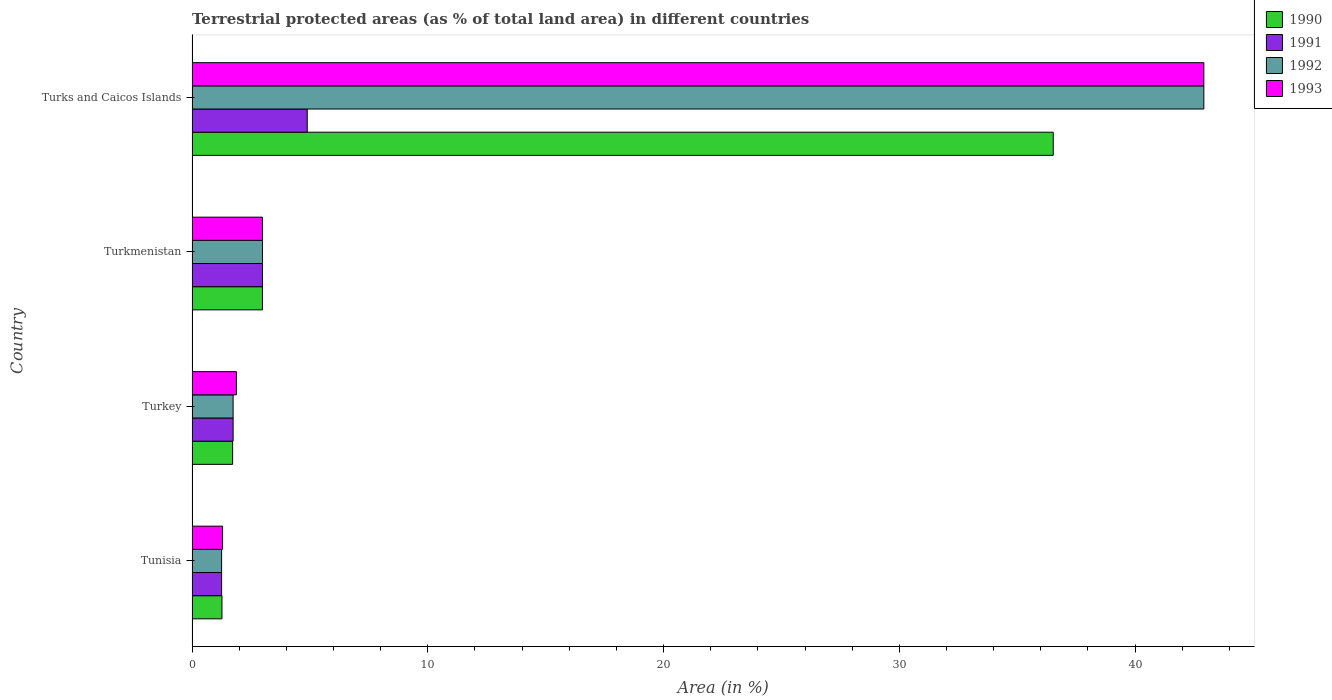Are the number of bars per tick equal to the number of legend labels?
Provide a succinct answer. Yes. Are the number of bars on each tick of the Y-axis equal?
Provide a succinct answer. Yes. How many bars are there on the 3rd tick from the top?
Provide a succinct answer. 4. How many bars are there on the 2nd tick from the bottom?
Ensure brevity in your answer.  4. What is the label of the 1st group of bars from the top?
Provide a short and direct response. Turks and Caicos Islands. What is the percentage of terrestrial protected land in 1990 in Turks and Caicos Islands?
Ensure brevity in your answer.  36.53. Across all countries, what is the maximum percentage of terrestrial protected land in 1992?
Keep it short and to the point. 42.92. Across all countries, what is the minimum percentage of terrestrial protected land in 1992?
Offer a very short reply. 1.25. In which country was the percentage of terrestrial protected land in 1993 maximum?
Keep it short and to the point. Turks and Caicos Islands. In which country was the percentage of terrestrial protected land in 1992 minimum?
Give a very brief answer. Tunisia. What is the total percentage of terrestrial protected land in 1991 in the graph?
Your answer should be very brief. 10.87. What is the difference between the percentage of terrestrial protected land in 1993 in Tunisia and that in Turkey?
Keep it short and to the point. -0.59. What is the difference between the percentage of terrestrial protected land in 1991 in Tunisia and the percentage of terrestrial protected land in 1992 in Turkey?
Provide a succinct answer. -0.49. What is the average percentage of terrestrial protected land in 1990 per country?
Keep it short and to the point. 10.63. What is the difference between the percentage of terrestrial protected land in 1990 and percentage of terrestrial protected land in 1993 in Tunisia?
Offer a terse response. -0.03. In how many countries, is the percentage of terrestrial protected land in 1993 greater than 12 %?
Make the answer very short. 1. What is the ratio of the percentage of terrestrial protected land in 1990 in Tunisia to that in Turkey?
Provide a succinct answer. 0.74. Is the percentage of terrestrial protected land in 1991 in Tunisia less than that in Turks and Caicos Islands?
Make the answer very short. Yes. What is the difference between the highest and the second highest percentage of terrestrial protected land in 1991?
Keep it short and to the point. 1.9. What is the difference between the highest and the lowest percentage of terrestrial protected land in 1992?
Your answer should be very brief. 41.66. In how many countries, is the percentage of terrestrial protected land in 1991 greater than the average percentage of terrestrial protected land in 1991 taken over all countries?
Your answer should be compact. 2. Is the sum of the percentage of terrestrial protected land in 1993 in Turkey and Turks and Caicos Islands greater than the maximum percentage of terrestrial protected land in 1992 across all countries?
Provide a short and direct response. Yes. What does the 3rd bar from the bottom in Tunisia represents?
Ensure brevity in your answer.  1992. What is the difference between two consecutive major ticks on the X-axis?
Keep it short and to the point. 10. Are the values on the major ticks of X-axis written in scientific E-notation?
Your answer should be compact. No. How many legend labels are there?
Offer a terse response. 4. What is the title of the graph?
Provide a succinct answer. Terrestrial protected areas (as % of total land area) in different countries. What is the label or title of the X-axis?
Offer a terse response. Area (in %). What is the Area (in %) in 1990 in Tunisia?
Your response must be concise. 1.27. What is the Area (in %) of 1991 in Tunisia?
Provide a short and direct response. 1.25. What is the Area (in %) in 1992 in Tunisia?
Give a very brief answer. 1.25. What is the Area (in %) of 1993 in Tunisia?
Offer a very short reply. 1.29. What is the Area (in %) in 1990 in Turkey?
Your answer should be very brief. 1.72. What is the Area (in %) of 1991 in Turkey?
Offer a very short reply. 1.74. What is the Area (in %) of 1992 in Turkey?
Offer a very short reply. 1.74. What is the Area (in %) of 1993 in Turkey?
Ensure brevity in your answer.  1.88. What is the Area (in %) in 1990 in Turkmenistan?
Offer a terse response. 2.99. What is the Area (in %) of 1991 in Turkmenistan?
Offer a terse response. 2.99. What is the Area (in %) in 1992 in Turkmenistan?
Provide a succinct answer. 2.99. What is the Area (in %) of 1993 in Turkmenistan?
Keep it short and to the point. 2.99. What is the Area (in %) in 1990 in Turks and Caicos Islands?
Your answer should be very brief. 36.53. What is the Area (in %) of 1991 in Turks and Caicos Islands?
Make the answer very short. 4.89. What is the Area (in %) of 1992 in Turks and Caicos Islands?
Offer a terse response. 42.92. What is the Area (in %) of 1993 in Turks and Caicos Islands?
Ensure brevity in your answer.  42.92. Across all countries, what is the maximum Area (in %) of 1990?
Provide a succinct answer. 36.53. Across all countries, what is the maximum Area (in %) of 1991?
Make the answer very short. 4.89. Across all countries, what is the maximum Area (in %) of 1992?
Provide a succinct answer. 42.92. Across all countries, what is the maximum Area (in %) of 1993?
Provide a short and direct response. 42.92. Across all countries, what is the minimum Area (in %) of 1990?
Offer a terse response. 1.27. Across all countries, what is the minimum Area (in %) of 1991?
Keep it short and to the point. 1.25. Across all countries, what is the minimum Area (in %) in 1992?
Your answer should be very brief. 1.25. Across all countries, what is the minimum Area (in %) in 1993?
Ensure brevity in your answer.  1.29. What is the total Area (in %) in 1990 in the graph?
Ensure brevity in your answer.  42.5. What is the total Area (in %) in 1991 in the graph?
Keep it short and to the point. 10.87. What is the total Area (in %) in 1992 in the graph?
Provide a succinct answer. 48.9. What is the total Area (in %) in 1993 in the graph?
Ensure brevity in your answer.  49.08. What is the difference between the Area (in %) of 1990 in Tunisia and that in Turkey?
Your answer should be compact. -0.45. What is the difference between the Area (in %) in 1991 in Tunisia and that in Turkey?
Your answer should be compact. -0.49. What is the difference between the Area (in %) in 1992 in Tunisia and that in Turkey?
Your answer should be compact. -0.49. What is the difference between the Area (in %) in 1993 in Tunisia and that in Turkey?
Make the answer very short. -0.59. What is the difference between the Area (in %) in 1990 in Tunisia and that in Turkmenistan?
Offer a terse response. -1.72. What is the difference between the Area (in %) in 1991 in Tunisia and that in Turkmenistan?
Make the answer very short. -1.73. What is the difference between the Area (in %) of 1992 in Tunisia and that in Turkmenistan?
Offer a very short reply. -1.73. What is the difference between the Area (in %) in 1993 in Tunisia and that in Turkmenistan?
Give a very brief answer. -1.69. What is the difference between the Area (in %) in 1990 in Tunisia and that in Turks and Caicos Islands?
Provide a succinct answer. -35.26. What is the difference between the Area (in %) of 1991 in Tunisia and that in Turks and Caicos Islands?
Give a very brief answer. -3.63. What is the difference between the Area (in %) of 1992 in Tunisia and that in Turks and Caicos Islands?
Keep it short and to the point. -41.66. What is the difference between the Area (in %) in 1993 in Tunisia and that in Turks and Caicos Islands?
Provide a short and direct response. -41.62. What is the difference between the Area (in %) in 1990 in Turkey and that in Turkmenistan?
Keep it short and to the point. -1.27. What is the difference between the Area (in %) in 1991 in Turkey and that in Turkmenistan?
Give a very brief answer. -1.24. What is the difference between the Area (in %) in 1992 in Turkey and that in Turkmenistan?
Your response must be concise. -1.24. What is the difference between the Area (in %) of 1993 in Turkey and that in Turkmenistan?
Ensure brevity in your answer.  -1.1. What is the difference between the Area (in %) in 1990 in Turkey and that in Turks and Caicos Islands?
Ensure brevity in your answer.  -34.81. What is the difference between the Area (in %) in 1991 in Turkey and that in Turks and Caicos Islands?
Provide a succinct answer. -3.14. What is the difference between the Area (in %) of 1992 in Turkey and that in Turks and Caicos Islands?
Ensure brevity in your answer.  -41.18. What is the difference between the Area (in %) of 1993 in Turkey and that in Turks and Caicos Islands?
Make the answer very short. -41.04. What is the difference between the Area (in %) of 1990 in Turkmenistan and that in Turks and Caicos Islands?
Provide a short and direct response. -33.54. What is the difference between the Area (in %) in 1991 in Turkmenistan and that in Turks and Caicos Islands?
Your answer should be very brief. -1.9. What is the difference between the Area (in %) of 1992 in Turkmenistan and that in Turks and Caicos Islands?
Give a very brief answer. -39.93. What is the difference between the Area (in %) in 1993 in Turkmenistan and that in Turks and Caicos Islands?
Provide a short and direct response. -39.93. What is the difference between the Area (in %) in 1990 in Tunisia and the Area (in %) in 1991 in Turkey?
Offer a terse response. -0.47. What is the difference between the Area (in %) of 1990 in Tunisia and the Area (in %) of 1992 in Turkey?
Your response must be concise. -0.47. What is the difference between the Area (in %) of 1990 in Tunisia and the Area (in %) of 1993 in Turkey?
Ensure brevity in your answer.  -0.61. What is the difference between the Area (in %) in 1991 in Tunisia and the Area (in %) in 1992 in Turkey?
Your answer should be very brief. -0.49. What is the difference between the Area (in %) in 1991 in Tunisia and the Area (in %) in 1993 in Turkey?
Your response must be concise. -0.63. What is the difference between the Area (in %) of 1992 in Tunisia and the Area (in %) of 1993 in Turkey?
Keep it short and to the point. -0.63. What is the difference between the Area (in %) in 1990 in Tunisia and the Area (in %) in 1991 in Turkmenistan?
Make the answer very short. -1.72. What is the difference between the Area (in %) in 1990 in Tunisia and the Area (in %) in 1992 in Turkmenistan?
Keep it short and to the point. -1.72. What is the difference between the Area (in %) in 1990 in Tunisia and the Area (in %) in 1993 in Turkmenistan?
Your answer should be very brief. -1.72. What is the difference between the Area (in %) in 1991 in Tunisia and the Area (in %) in 1992 in Turkmenistan?
Offer a terse response. -1.73. What is the difference between the Area (in %) in 1991 in Tunisia and the Area (in %) in 1993 in Turkmenistan?
Offer a very short reply. -1.73. What is the difference between the Area (in %) of 1992 in Tunisia and the Area (in %) of 1993 in Turkmenistan?
Your answer should be compact. -1.73. What is the difference between the Area (in %) in 1990 in Tunisia and the Area (in %) in 1991 in Turks and Caicos Islands?
Provide a short and direct response. -3.62. What is the difference between the Area (in %) in 1990 in Tunisia and the Area (in %) in 1992 in Turks and Caicos Islands?
Offer a terse response. -41.65. What is the difference between the Area (in %) of 1990 in Tunisia and the Area (in %) of 1993 in Turks and Caicos Islands?
Provide a succinct answer. -41.65. What is the difference between the Area (in %) of 1991 in Tunisia and the Area (in %) of 1992 in Turks and Caicos Islands?
Offer a terse response. -41.66. What is the difference between the Area (in %) of 1991 in Tunisia and the Area (in %) of 1993 in Turks and Caicos Islands?
Ensure brevity in your answer.  -41.66. What is the difference between the Area (in %) in 1992 in Tunisia and the Area (in %) in 1993 in Turks and Caicos Islands?
Provide a succinct answer. -41.66. What is the difference between the Area (in %) of 1990 in Turkey and the Area (in %) of 1991 in Turkmenistan?
Provide a succinct answer. -1.27. What is the difference between the Area (in %) of 1990 in Turkey and the Area (in %) of 1992 in Turkmenistan?
Provide a short and direct response. -1.27. What is the difference between the Area (in %) of 1990 in Turkey and the Area (in %) of 1993 in Turkmenistan?
Ensure brevity in your answer.  -1.27. What is the difference between the Area (in %) in 1991 in Turkey and the Area (in %) in 1992 in Turkmenistan?
Your answer should be compact. -1.24. What is the difference between the Area (in %) in 1991 in Turkey and the Area (in %) in 1993 in Turkmenistan?
Keep it short and to the point. -1.24. What is the difference between the Area (in %) in 1992 in Turkey and the Area (in %) in 1993 in Turkmenistan?
Offer a very short reply. -1.24. What is the difference between the Area (in %) of 1990 in Turkey and the Area (in %) of 1991 in Turks and Caicos Islands?
Offer a terse response. -3.17. What is the difference between the Area (in %) of 1990 in Turkey and the Area (in %) of 1992 in Turks and Caicos Islands?
Provide a short and direct response. -41.2. What is the difference between the Area (in %) in 1990 in Turkey and the Area (in %) in 1993 in Turks and Caicos Islands?
Give a very brief answer. -41.2. What is the difference between the Area (in %) in 1991 in Turkey and the Area (in %) in 1992 in Turks and Caicos Islands?
Offer a terse response. -41.18. What is the difference between the Area (in %) in 1991 in Turkey and the Area (in %) in 1993 in Turks and Caicos Islands?
Ensure brevity in your answer.  -41.18. What is the difference between the Area (in %) in 1992 in Turkey and the Area (in %) in 1993 in Turks and Caicos Islands?
Your answer should be very brief. -41.18. What is the difference between the Area (in %) of 1990 in Turkmenistan and the Area (in %) of 1991 in Turks and Caicos Islands?
Your answer should be compact. -1.9. What is the difference between the Area (in %) of 1990 in Turkmenistan and the Area (in %) of 1992 in Turks and Caicos Islands?
Offer a very short reply. -39.93. What is the difference between the Area (in %) in 1990 in Turkmenistan and the Area (in %) in 1993 in Turks and Caicos Islands?
Provide a succinct answer. -39.93. What is the difference between the Area (in %) of 1991 in Turkmenistan and the Area (in %) of 1992 in Turks and Caicos Islands?
Your answer should be very brief. -39.93. What is the difference between the Area (in %) in 1991 in Turkmenistan and the Area (in %) in 1993 in Turks and Caicos Islands?
Ensure brevity in your answer.  -39.93. What is the difference between the Area (in %) of 1992 in Turkmenistan and the Area (in %) of 1993 in Turks and Caicos Islands?
Make the answer very short. -39.93. What is the average Area (in %) of 1990 per country?
Give a very brief answer. 10.63. What is the average Area (in %) of 1991 per country?
Ensure brevity in your answer.  2.72. What is the average Area (in %) of 1992 per country?
Give a very brief answer. 12.22. What is the average Area (in %) of 1993 per country?
Your answer should be very brief. 12.27. What is the difference between the Area (in %) of 1990 and Area (in %) of 1991 in Tunisia?
Give a very brief answer. 0.01. What is the difference between the Area (in %) of 1990 and Area (in %) of 1992 in Tunisia?
Your answer should be very brief. 0.01. What is the difference between the Area (in %) in 1990 and Area (in %) in 1993 in Tunisia?
Your answer should be compact. -0.03. What is the difference between the Area (in %) of 1991 and Area (in %) of 1992 in Tunisia?
Provide a short and direct response. 0. What is the difference between the Area (in %) of 1991 and Area (in %) of 1993 in Tunisia?
Make the answer very short. -0.04. What is the difference between the Area (in %) of 1992 and Area (in %) of 1993 in Tunisia?
Your response must be concise. -0.04. What is the difference between the Area (in %) of 1990 and Area (in %) of 1991 in Turkey?
Offer a terse response. -0.02. What is the difference between the Area (in %) of 1990 and Area (in %) of 1992 in Turkey?
Your response must be concise. -0.02. What is the difference between the Area (in %) in 1990 and Area (in %) in 1993 in Turkey?
Your answer should be compact. -0.16. What is the difference between the Area (in %) in 1991 and Area (in %) in 1992 in Turkey?
Keep it short and to the point. 0. What is the difference between the Area (in %) in 1991 and Area (in %) in 1993 in Turkey?
Give a very brief answer. -0.14. What is the difference between the Area (in %) in 1992 and Area (in %) in 1993 in Turkey?
Give a very brief answer. -0.14. What is the difference between the Area (in %) in 1990 and Area (in %) in 1991 in Turkmenistan?
Offer a very short reply. -0. What is the difference between the Area (in %) in 1990 and Area (in %) in 1993 in Turkmenistan?
Your answer should be compact. -0. What is the difference between the Area (in %) in 1991 and Area (in %) in 1992 in Turkmenistan?
Offer a very short reply. 0. What is the difference between the Area (in %) of 1991 and Area (in %) of 1993 in Turkmenistan?
Offer a terse response. 0. What is the difference between the Area (in %) of 1990 and Area (in %) of 1991 in Turks and Caicos Islands?
Give a very brief answer. 31.64. What is the difference between the Area (in %) of 1990 and Area (in %) of 1992 in Turks and Caicos Islands?
Ensure brevity in your answer.  -6.39. What is the difference between the Area (in %) in 1990 and Area (in %) in 1993 in Turks and Caicos Islands?
Make the answer very short. -6.39. What is the difference between the Area (in %) in 1991 and Area (in %) in 1992 in Turks and Caicos Islands?
Your answer should be very brief. -38.03. What is the difference between the Area (in %) of 1991 and Area (in %) of 1993 in Turks and Caicos Islands?
Make the answer very short. -38.03. What is the ratio of the Area (in %) of 1990 in Tunisia to that in Turkey?
Your response must be concise. 0.74. What is the ratio of the Area (in %) of 1991 in Tunisia to that in Turkey?
Ensure brevity in your answer.  0.72. What is the ratio of the Area (in %) of 1992 in Tunisia to that in Turkey?
Ensure brevity in your answer.  0.72. What is the ratio of the Area (in %) in 1993 in Tunisia to that in Turkey?
Give a very brief answer. 0.69. What is the ratio of the Area (in %) in 1990 in Tunisia to that in Turkmenistan?
Provide a short and direct response. 0.42. What is the ratio of the Area (in %) in 1991 in Tunisia to that in Turkmenistan?
Provide a short and direct response. 0.42. What is the ratio of the Area (in %) in 1992 in Tunisia to that in Turkmenistan?
Provide a short and direct response. 0.42. What is the ratio of the Area (in %) in 1993 in Tunisia to that in Turkmenistan?
Your answer should be very brief. 0.43. What is the ratio of the Area (in %) of 1990 in Tunisia to that in Turks and Caicos Islands?
Your answer should be very brief. 0.03. What is the ratio of the Area (in %) in 1991 in Tunisia to that in Turks and Caicos Islands?
Offer a very short reply. 0.26. What is the ratio of the Area (in %) in 1992 in Tunisia to that in Turks and Caicos Islands?
Offer a very short reply. 0.03. What is the ratio of the Area (in %) of 1993 in Tunisia to that in Turks and Caicos Islands?
Offer a terse response. 0.03. What is the ratio of the Area (in %) in 1990 in Turkey to that in Turkmenistan?
Your answer should be very brief. 0.58. What is the ratio of the Area (in %) in 1991 in Turkey to that in Turkmenistan?
Keep it short and to the point. 0.58. What is the ratio of the Area (in %) of 1992 in Turkey to that in Turkmenistan?
Give a very brief answer. 0.58. What is the ratio of the Area (in %) in 1993 in Turkey to that in Turkmenistan?
Make the answer very short. 0.63. What is the ratio of the Area (in %) in 1990 in Turkey to that in Turks and Caicos Islands?
Keep it short and to the point. 0.05. What is the ratio of the Area (in %) of 1991 in Turkey to that in Turks and Caicos Islands?
Make the answer very short. 0.36. What is the ratio of the Area (in %) in 1992 in Turkey to that in Turks and Caicos Islands?
Your response must be concise. 0.04. What is the ratio of the Area (in %) in 1993 in Turkey to that in Turks and Caicos Islands?
Offer a very short reply. 0.04. What is the ratio of the Area (in %) in 1990 in Turkmenistan to that in Turks and Caicos Islands?
Your answer should be very brief. 0.08. What is the ratio of the Area (in %) of 1991 in Turkmenistan to that in Turks and Caicos Islands?
Make the answer very short. 0.61. What is the ratio of the Area (in %) in 1992 in Turkmenistan to that in Turks and Caicos Islands?
Your answer should be very brief. 0.07. What is the ratio of the Area (in %) in 1993 in Turkmenistan to that in Turks and Caicos Islands?
Provide a short and direct response. 0.07. What is the difference between the highest and the second highest Area (in %) of 1990?
Give a very brief answer. 33.54. What is the difference between the highest and the second highest Area (in %) in 1991?
Your response must be concise. 1.9. What is the difference between the highest and the second highest Area (in %) in 1992?
Offer a very short reply. 39.93. What is the difference between the highest and the second highest Area (in %) in 1993?
Make the answer very short. 39.93. What is the difference between the highest and the lowest Area (in %) of 1990?
Offer a very short reply. 35.26. What is the difference between the highest and the lowest Area (in %) in 1991?
Make the answer very short. 3.63. What is the difference between the highest and the lowest Area (in %) of 1992?
Your answer should be compact. 41.66. What is the difference between the highest and the lowest Area (in %) in 1993?
Ensure brevity in your answer.  41.62. 